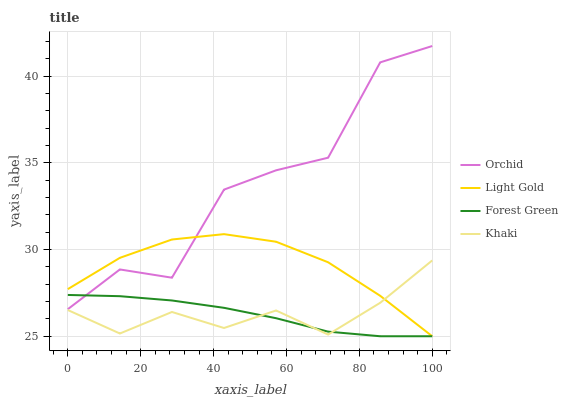Does Khaki have the minimum area under the curve?
Answer yes or no. Yes. Does Orchid have the maximum area under the curve?
Answer yes or no. Yes. Does Light Gold have the minimum area under the curve?
Answer yes or no. No. Does Light Gold have the maximum area under the curve?
Answer yes or no. No. Is Forest Green the smoothest?
Answer yes or no. Yes. Is Orchid the roughest?
Answer yes or no. Yes. Is Khaki the smoothest?
Answer yes or no. No. Is Khaki the roughest?
Answer yes or no. No. Does Forest Green have the lowest value?
Answer yes or no. Yes. Does Khaki have the lowest value?
Answer yes or no. No. Does Orchid have the highest value?
Answer yes or no. Yes. Does Khaki have the highest value?
Answer yes or no. No. Is Khaki less than Orchid?
Answer yes or no. Yes. Is Orchid greater than Khaki?
Answer yes or no. Yes. Does Light Gold intersect Khaki?
Answer yes or no. Yes. Is Light Gold less than Khaki?
Answer yes or no. No. Is Light Gold greater than Khaki?
Answer yes or no. No. Does Khaki intersect Orchid?
Answer yes or no. No. 